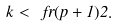<formula> <loc_0><loc_0><loc_500><loc_500>k < \ f r { ( p + 1 ) } { 2 } .</formula> 